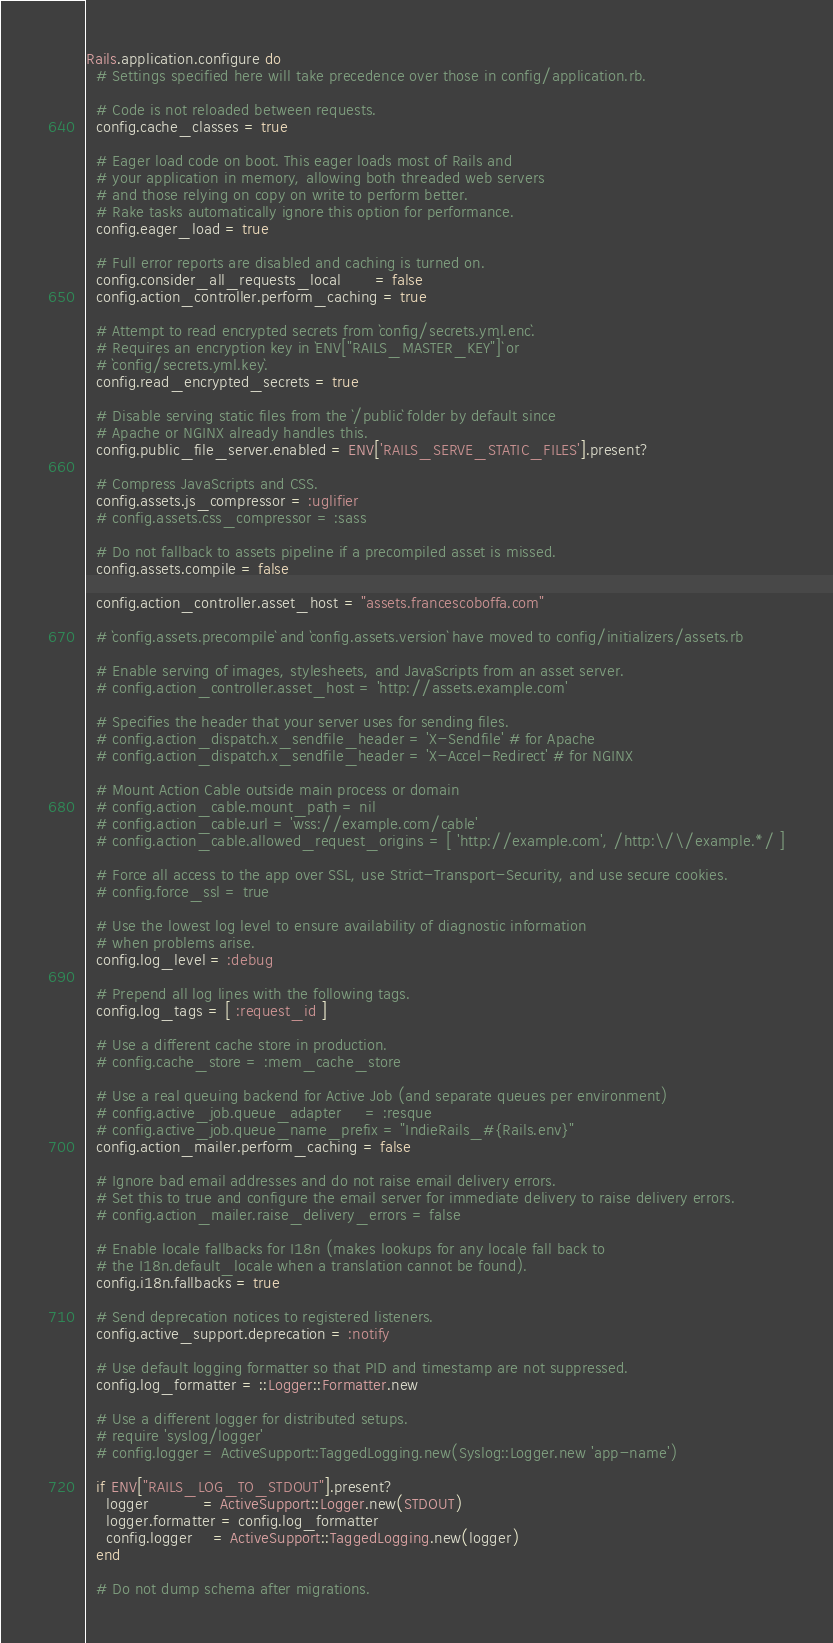Convert code to text. <code><loc_0><loc_0><loc_500><loc_500><_Ruby_>Rails.application.configure do
  # Settings specified here will take precedence over those in config/application.rb.

  # Code is not reloaded between requests.
  config.cache_classes = true

  # Eager load code on boot. This eager loads most of Rails and
  # your application in memory, allowing both threaded web servers
  # and those relying on copy on write to perform better.
  # Rake tasks automatically ignore this option for performance.
  config.eager_load = true

  # Full error reports are disabled and caching is turned on.
  config.consider_all_requests_local       = false
  config.action_controller.perform_caching = true

  # Attempt to read encrypted secrets from `config/secrets.yml.enc`.
  # Requires an encryption key in `ENV["RAILS_MASTER_KEY"]` or
  # `config/secrets.yml.key`.
  config.read_encrypted_secrets = true

  # Disable serving static files from the `/public` folder by default since
  # Apache or NGINX already handles this.
  config.public_file_server.enabled = ENV['RAILS_SERVE_STATIC_FILES'].present?

  # Compress JavaScripts and CSS.
  config.assets.js_compressor = :uglifier
  # config.assets.css_compressor = :sass

  # Do not fallback to assets pipeline if a precompiled asset is missed.
  config.assets.compile = false

  config.action_controller.asset_host = "assets.francescoboffa.com"

  # `config.assets.precompile` and `config.assets.version` have moved to config/initializers/assets.rb

  # Enable serving of images, stylesheets, and JavaScripts from an asset server.
  # config.action_controller.asset_host = 'http://assets.example.com'

  # Specifies the header that your server uses for sending files.
  # config.action_dispatch.x_sendfile_header = 'X-Sendfile' # for Apache
  # config.action_dispatch.x_sendfile_header = 'X-Accel-Redirect' # for NGINX

  # Mount Action Cable outside main process or domain
  # config.action_cable.mount_path = nil
  # config.action_cable.url = 'wss://example.com/cable'
  # config.action_cable.allowed_request_origins = [ 'http://example.com', /http:\/\/example.*/ ]

  # Force all access to the app over SSL, use Strict-Transport-Security, and use secure cookies.
  # config.force_ssl = true

  # Use the lowest log level to ensure availability of diagnostic information
  # when problems arise.
  config.log_level = :debug

  # Prepend all log lines with the following tags.
  config.log_tags = [ :request_id ]

  # Use a different cache store in production.
  # config.cache_store = :mem_cache_store

  # Use a real queuing backend for Active Job (and separate queues per environment)
  # config.active_job.queue_adapter     = :resque
  # config.active_job.queue_name_prefix = "IndieRails_#{Rails.env}"
  config.action_mailer.perform_caching = false

  # Ignore bad email addresses and do not raise email delivery errors.
  # Set this to true and configure the email server for immediate delivery to raise delivery errors.
  # config.action_mailer.raise_delivery_errors = false

  # Enable locale fallbacks for I18n (makes lookups for any locale fall back to
  # the I18n.default_locale when a translation cannot be found).
  config.i18n.fallbacks = true

  # Send deprecation notices to registered listeners.
  config.active_support.deprecation = :notify

  # Use default logging formatter so that PID and timestamp are not suppressed.
  config.log_formatter = ::Logger::Formatter.new

  # Use a different logger for distributed setups.
  # require 'syslog/logger'
  # config.logger = ActiveSupport::TaggedLogging.new(Syslog::Logger.new 'app-name')

  if ENV["RAILS_LOG_TO_STDOUT"].present?
    logger           = ActiveSupport::Logger.new(STDOUT)
    logger.formatter = config.log_formatter
    config.logger    = ActiveSupport::TaggedLogging.new(logger)
  end

  # Do not dump schema after migrations.</code> 